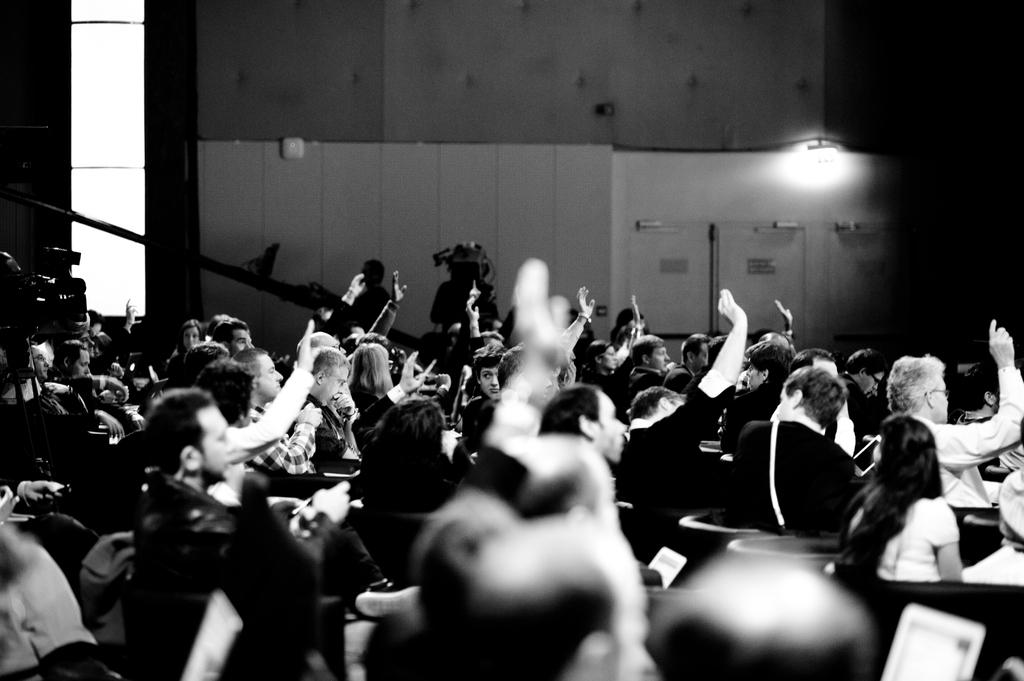What are the people in the image doing? The people in the image are standing and raising their hands. Can you describe the person holding an object in the image? There is a person holding a camera in the image. What can be seen in the background of the image? There is a wall with a light in the background of the image. What type of scene is the bear performing in the image? There is no bear present in the image, so it is not possible to answer that question. 